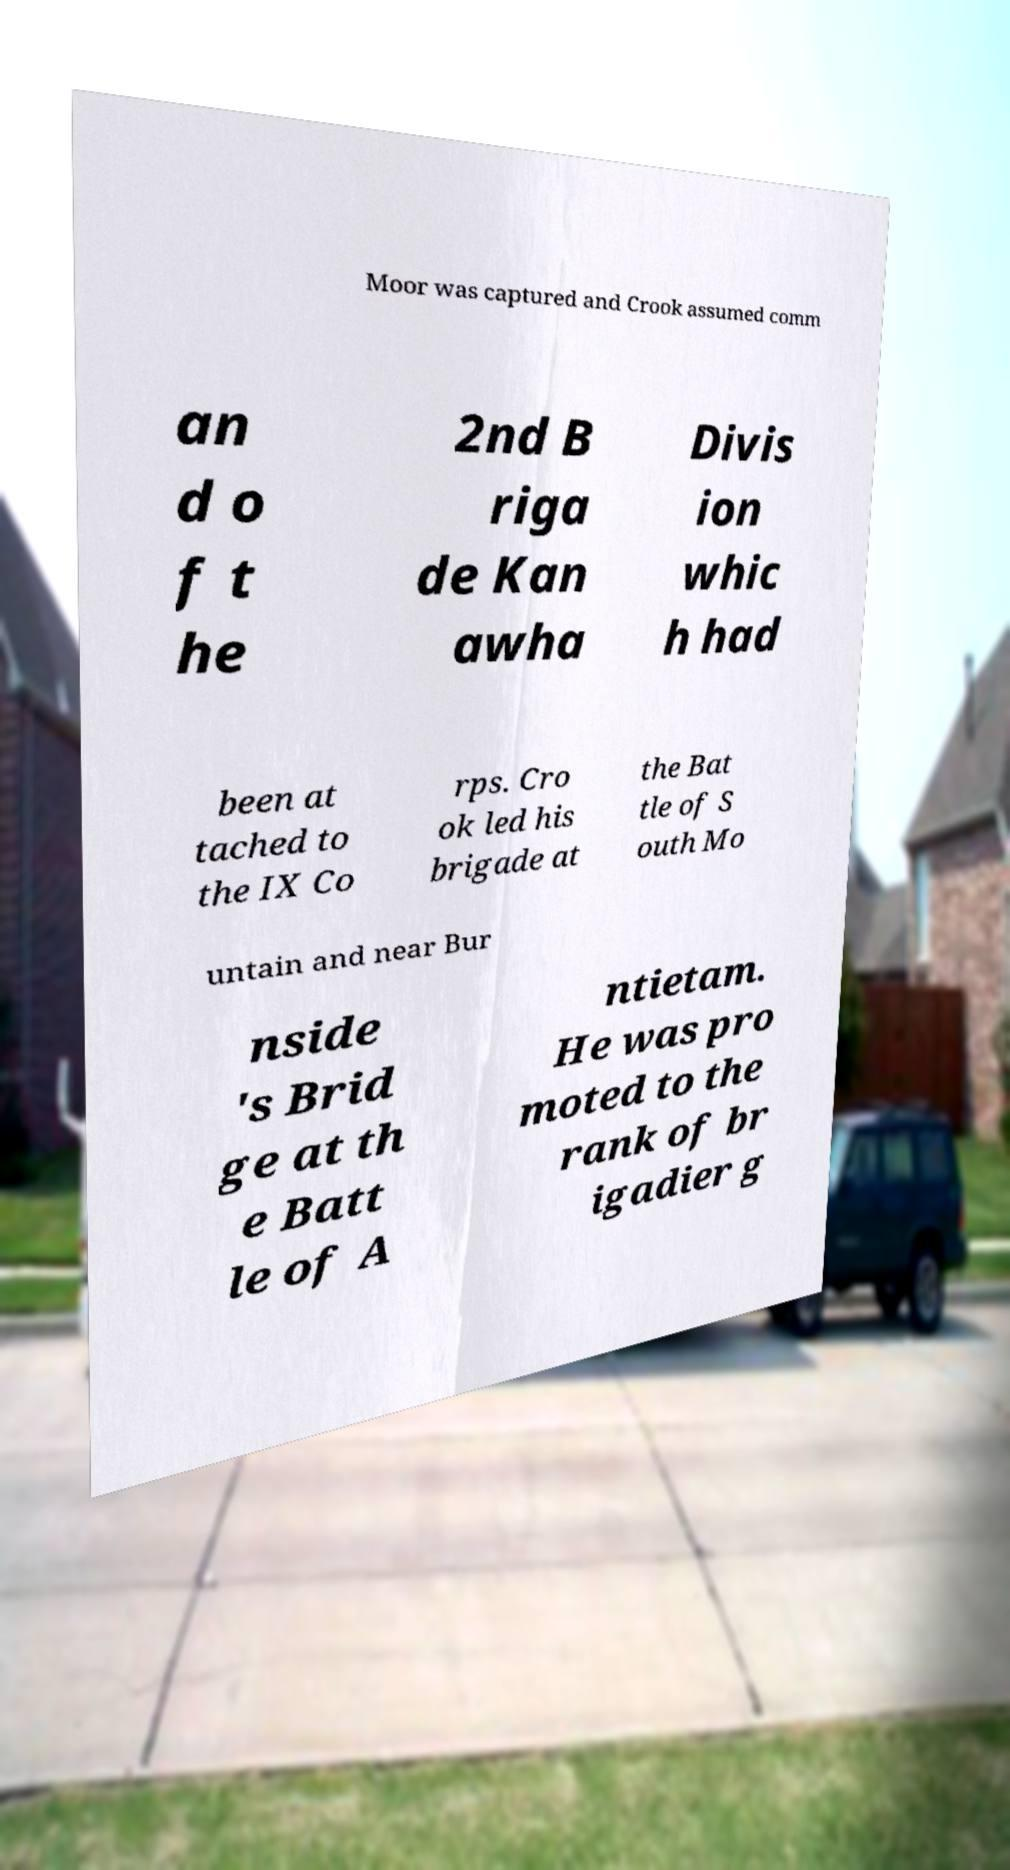Can you accurately transcribe the text from the provided image for me? Moor was captured and Crook assumed comm an d o f t he 2nd B riga de Kan awha Divis ion whic h had been at tached to the IX Co rps. Cro ok led his brigade at the Bat tle of S outh Mo untain and near Bur nside 's Brid ge at th e Batt le of A ntietam. He was pro moted to the rank of br igadier g 